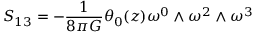<formula> <loc_0><loc_0><loc_500><loc_500>S _ { 1 3 } = - \frac { 1 } { 8 { \pi } G } { \theta } _ { 0 } ( z ) { \omega } ^ { 0 } \wedge { \omega } ^ { 2 } \wedge { \omega } ^ { 3 }</formula> 